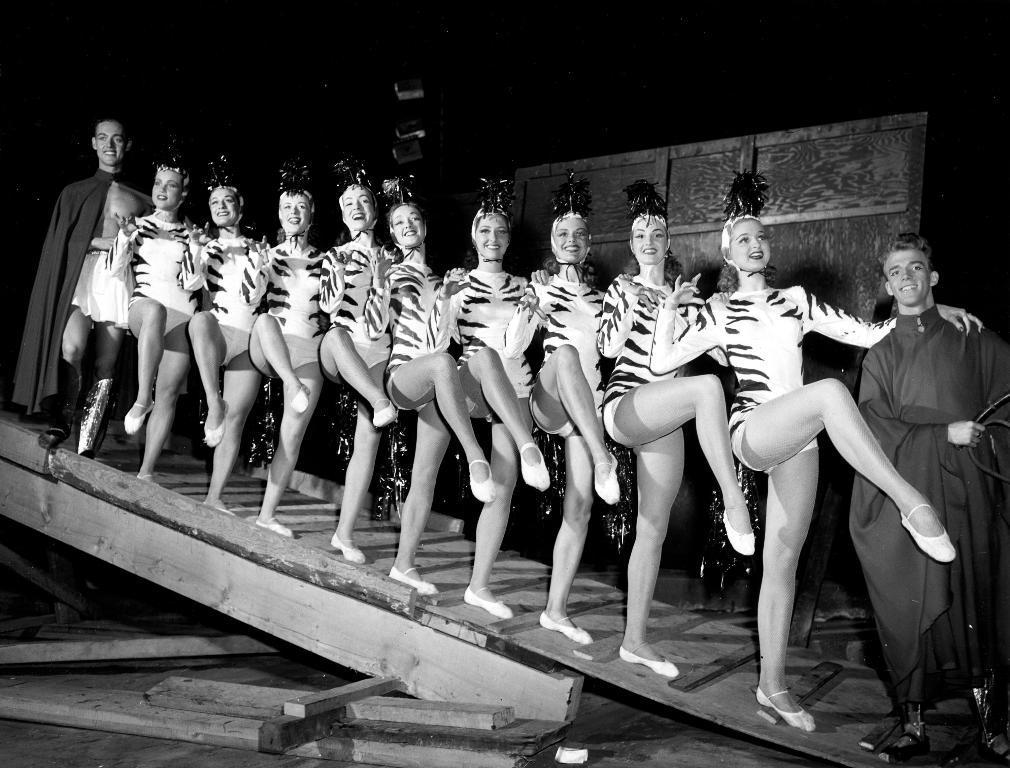Can you describe this image briefly? In this image I can see the group of people standing and wearing the dresses. These people are standing on the wooden surface. And this is a black and white image. 